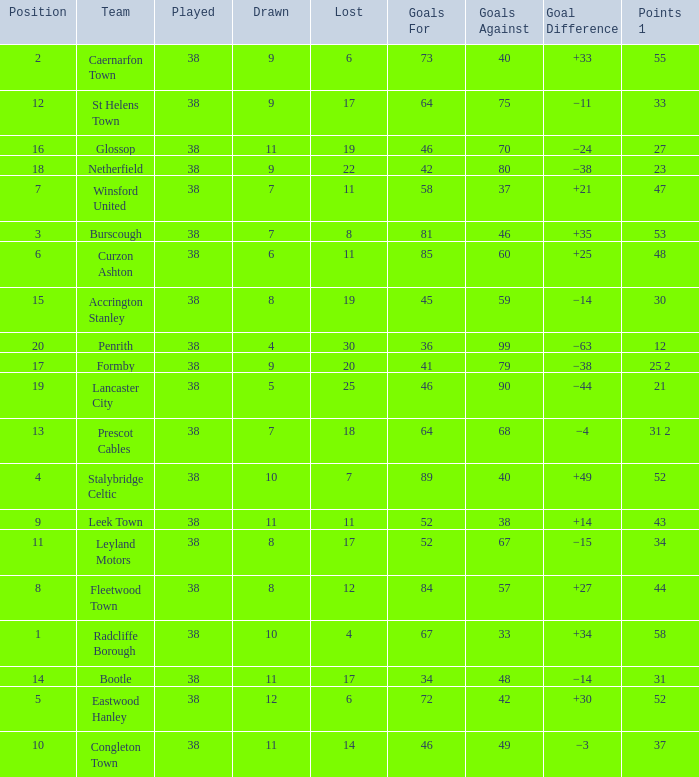WHAT IS THE SUM PLAYED WITH POINTS 1 OF 53, AND POSITION LARGER THAN 3? None. 